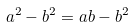Convert formula to latex. <formula><loc_0><loc_0><loc_500><loc_500>a ^ { 2 } - b ^ { 2 } = a b - b ^ { 2 }</formula> 